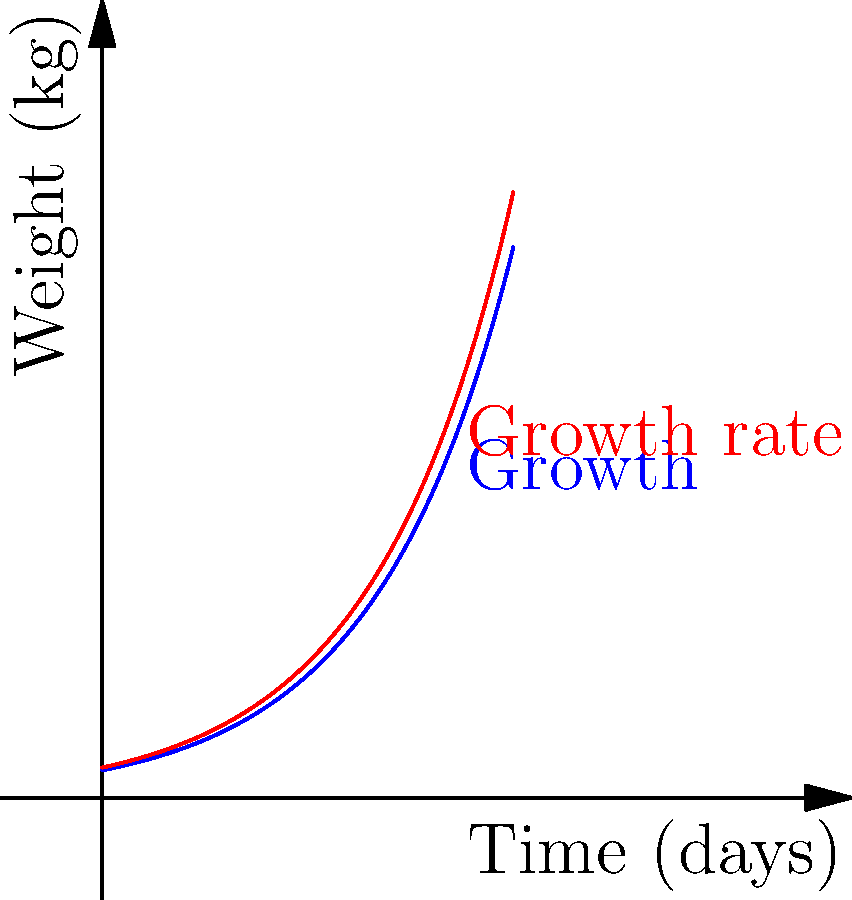A CSA farm is tracking the growth of their organic kale plants. The weight (in kg) of a kale plant after $t$ days is modeled by the function $W(t) = 2e^{0.1t}$. Calculate the growth rate of the kale plant after 20 days. To find the growth rate, we need to calculate the derivative of the weight function at $t = 20$.

1) The weight function is $W(t) = 2e^{0.1t}$

2) The derivative of $W(t)$ gives us the growth rate function:
   $W'(t) = 2 \cdot 0.1 \cdot e^{0.1t} = 0.2e^{0.1t}$

3) To find the growth rate at 20 days, we evaluate $W'(20)$:
   $W'(20) = 0.2e^{0.1 \cdot 20} = 0.2e^2$

4) Calculate $e^2 \approx 7.3891$

5) Multiply: $0.2 \cdot 7.3891 \approx 1.4778$

Therefore, the growth rate of the kale plant after 20 days is approximately 1.4778 kg/day.
Answer: 1.4778 kg/day 